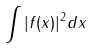Convert formula to latex. <formula><loc_0><loc_0><loc_500><loc_500>\int | f ( x ) | ^ { 2 } d x</formula> 